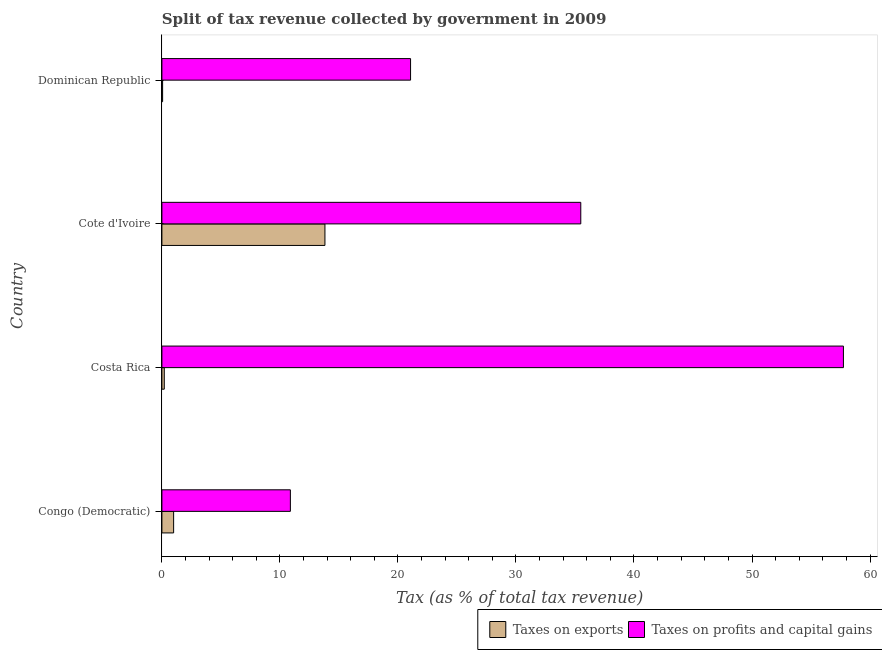How many different coloured bars are there?
Your answer should be very brief. 2. Are the number of bars per tick equal to the number of legend labels?
Give a very brief answer. Yes. Are the number of bars on each tick of the Y-axis equal?
Offer a very short reply. Yes. How many bars are there on the 4th tick from the bottom?
Give a very brief answer. 2. What is the percentage of revenue obtained from taxes on profits and capital gains in Dominican Republic?
Your answer should be compact. 21.07. Across all countries, what is the maximum percentage of revenue obtained from taxes on exports?
Your answer should be very brief. 13.81. Across all countries, what is the minimum percentage of revenue obtained from taxes on exports?
Make the answer very short. 0.06. In which country was the percentage of revenue obtained from taxes on exports maximum?
Give a very brief answer. Cote d'Ivoire. In which country was the percentage of revenue obtained from taxes on exports minimum?
Your answer should be compact. Dominican Republic. What is the total percentage of revenue obtained from taxes on exports in the graph?
Make the answer very short. 15.07. What is the difference between the percentage of revenue obtained from taxes on profits and capital gains in Costa Rica and that in Cote d'Ivoire?
Offer a very short reply. 22.25. What is the difference between the percentage of revenue obtained from taxes on profits and capital gains in Costa Rica and the percentage of revenue obtained from taxes on exports in Congo (Democratic)?
Offer a very short reply. 56.75. What is the average percentage of revenue obtained from taxes on profits and capital gains per country?
Your response must be concise. 31.3. What is the difference between the percentage of revenue obtained from taxes on exports and percentage of revenue obtained from taxes on profits and capital gains in Congo (Democratic)?
Your response must be concise. -9.89. What is the ratio of the percentage of revenue obtained from taxes on profits and capital gains in Costa Rica to that in Dominican Republic?
Ensure brevity in your answer.  2.74. What is the difference between the highest and the second highest percentage of revenue obtained from taxes on exports?
Ensure brevity in your answer.  12.82. What is the difference between the highest and the lowest percentage of revenue obtained from taxes on exports?
Offer a very short reply. 13.75. In how many countries, is the percentage of revenue obtained from taxes on profits and capital gains greater than the average percentage of revenue obtained from taxes on profits and capital gains taken over all countries?
Offer a terse response. 2. Is the sum of the percentage of revenue obtained from taxes on exports in Costa Rica and Cote d'Ivoire greater than the maximum percentage of revenue obtained from taxes on profits and capital gains across all countries?
Your answer should be very brief. No. What does the 1st bar from the top in Costa Rica represents?
Make the answer very short. Taxes on profits and capital gains. What does the 1st bar from the bottom in Dominican Republic represents?
Provide a short and direct response. Taxes on exports. How many bars are there?
Your answer should be very brief. 8. Are all the bars in the graph horizontal?
Your response must be concise. Yes. How many countries are there in the graph?
Your answer should be very brief. 4. Are the values on the major ticks of X-axis written in scientific E-notation?
Your response must be concise. No. Does the graph contain any zero values?
Keep it short and to the point. No. How many legend labels are there?
Give a very brief answer. 2. How are the legend labels stacked?
Offer a terse response. Horizontal. What is the title of the graph?
Make the answer very short. Split of tax revenue collected by government in 2009. Does "Gasoline" appear as one of the legend labels in the graph?
Give a very brief answer. No. What is the label or title of the X-axis?
Your response must be concise. Tax (as % of total tax revenue). What is the label or title of the Y-axis?
Your response must be concise. Country. What is the Tax (as % of total tax revenue) of Taxes on exports in Congo (Democratic)?
Provide a short and direct response. 0.99. What is the Tax (as % of total tax revenue) of Taxes on profits and capital gains in Congo (Democratic)?
Provide a short and direct response. 10.89. What is the Tax (as % of total tax revenue) in Taxes on exports in Costa Rica?
Offer a terse response. 0.2. What is the Tax (as % of total tax revenue) of Taxes on profits and capital gains in Costa Rica?
Your response must be concise. 57.75. What is the Tax (as % of total tax revenue) of Taxes on exports in Cote d'Ivoire?
Your answer should be compact. 13.81. What is the Tax (as % of total tax revenue) in Taxes on profits and capital gains in Cote d'Ivoire?
Your response must be concise. 35.49. What is the Tax (as % of total tax revenue) in Taxes on exports in Dominican Republic?
Your answer should be compact. 0.06. What is the Tax (as % of total tax revenue) in Taxes on profits and capital gains in Dominican Republic?
Offer a terse response. 21.07. Across all countries, what is the maximum Tax (as % of total tax revenue) of Taxes on exports?
Offer a terse response. 13.81. Across all countries, what is the maximum Tax (as % of total tax revenue) of Taxes on profits and capital gains?
Provide a short and direct response. 57.75. Across all countries, what is the minimum Tax (as % of total tax revenue) of Taxes on exports?
Offer a terse response. 0.06. Across all countries, what is the minimum Tax (as % of total tax revenue) in Taxes on profits and capital gains?
Give a very brief answer. 10.89. What is the total Tax (as % of total tax revenue) in Taxes on exports in the graph?
Keep it short and to the point. 15.07. What is the total Tax (as % of total tax revenue) of Taxes on profits and capital gains in the graph?
Provide a short and direct response. 125.19. What is the difference between the Tax (as % of total tax revenue) of Taxes on exports in Congo (Democratic) and that in Costa Rica?
Give a very brief answer. 0.79. What is the difference between the Tax (as % of total tax revenue) of Taxes on profits and capital gains in Congo (Democratic) and that in Costa Rica?
Your answer should be very brief. -46.86. What is the difference between the Tax (as % of total tax revenue) in Taxes on exports in Congo (Democratic) and that in Cote d'Ivoire?
Keep it short and to the point. -12.82. What is the difference between the Tax (as % of total tax revenue) of Taxes on profits and capital gains in Congo (Democratic) and that in Cote d'Ivoire?
Keep it short and to the point. -24.61. What is the difference between the Tax (as % of total tax revenue) of Taxes on exports in Congo (Democratic) and that in Dominican Republic?
Provide a succinct answer. 0.93. What is the difference between the Tax (as % of total tax revenue) in Taxes on profits and capital gains in Congo (Democratic) and that in Dominican Republic?
Ensure brevity in your answer.  -10.18. What is the difference between the Tax (as % of total tax revenue) in Taxes on exports in Costa Rica and that in Cote d'Ivoire?
Make the answer very short. -13.61. What is the difference between the Tax (as % of total tax revenue) of Taxes on profits and capital gains in Costa Rica and that in Cote d'Ivoire?
Keep it short and to the point. 22.25. What is the difference between the Tax (as % of total tax revenue) of Taxes on exports in Costa Rica and that in Dominican Republic?
Keep it short and to the point. 0.14. What is the difference between the Tax (as % of total tax revenue) of Taxes on profits and capital gains in Costa Rica and that in Dominican Republic?
Offer a terse response. 36.68. What is the difference between the Tax (as % of total tax revenue) of Taxes on exports in Cote d'Ivoire and that in Dominican Republic?
Keep it short and to the point. 13.75. What is the difference between the Tax (as % of total tax revenue) of Taxes on profits and capital gains in Cote d'Ivoire and that in Dominican Republic?
Your answer should be compact. 14.42. What is the difference between the Tax (as % of total tax revenue) in Taxes on exports in Congo (Democratic) and the Tax (as % of total tax revenue) in Taxes on profits and capital gains in Costa Rica?
Your answer should be compact. -56.75. What is the difference between the Tax (as % of total tax revenue) of Taxes on exports in Congo (Democratic) and the Tax (as % of total tax revenue) of Taxes on profits and capital gains in Cote d'Ivoire?
Your answer should be very brief. -34.5. What is the difference between the Tax (as % of total tax revenue) in Taxes on exports in Congo (Democratic) and the Tax (as % of total tax revenue) in Taxes on profits and capital gains in Dominican Republic?
Your response must be concise. -20.08. What is the difference between the Tax (as % of total tax revenue) of Taxes on exports in Costa Rica and the Tax (as % of total tax revenue) of Taxes on profits and capital gains in Cote d'Ivoire?
Offer a very short reply. -35.29. What is the difference between the Tax (as % of total tax revenue) in Taxes on exports in Costa Rica and the Tax (as % of total tax revenue) in Taxes on profits and capital gains in Dominican Republic?
Your answer should be very brief. -20.87. What is the difference between the Tax (as % of total tax revenue) in Taxes on exports in Cote d'Ivoire and the Tax (as % of total tax revenue) in Taxes on profits and capital gains in Dominican Republic?
Keep it short and to the point. -7.26. What is the average Tax (as % of total tax revenue) in Taxes on exports per country?
Make the answer very short. 3.77. What is the average Tax (as % of total tax revenue) in Taxes on profits and capital gains per country?
Your answer should be very brief. 31.3. What is the difference between the Tax (as % of total tax revenue) in Taxes on exports and Tax (as % of total tax revenue) in Taxes on profits and capital gains in Congo (Democratic)?
Ensure brevity in your answer.  -9.89. What is the difference between the Tax (as % of total tax revenue) in Taxes on exports and Tax (as % of total tax revenue) in Taxes on profits and capital gains in Costa Rica?
Offer a terse response. -57.54. What is the difference between the Tax (as % of total tax revenue) of Taxes on exports and Tax (as % of total tax revenue) of Taxes on profits and capital gains in Cote d'Ivoire?
Give a very brief answer. -21.68. What is the difference between the Tax (as % of total tax revenue) of Taxes on exports and Tax (as % of total tax revenue) of Taxes on profits and capital gains in Dominican Republic?
Offer a very short reply. -21.01. What is the ratio of the Tax (as % of total tax revenue) in Taxes on exports in Congo (Democratic) to that in Costa Rica?
Your response must be concise. 4.93. What is the ratio of the Tax (as % of total tax revenue) in Taxes on profits and capital gains in Congo (Democratic) to that in Costa Rica?
Your answer should be very brief. 0.19. What is the ratio of the Tax (as % of total tax revenue) in Taxes on exports in Congo (Democratic) to that in Cote d'Ivoire?
Your answer should be very brief. 0.07. What is the ratio of the Tax (as % of total tax revenue) of Taxes on profits and capital gains in Congo (Democratic) to that in Cote d'Ivoire?
Give a very brief answer. 0.31. What is the ratio of the Tax (as % of total tax revenue) of Taxes on exports in Congo (Democratic) to that in Dominican Republic?
Provide a succinct answer. 16.54. What is the ratio of the Tax (as % of total tax revenue) of Taxes on profits and capital gains in Congo (Democratic) to that in Dominican Republic?
Your response must be concise. 0.52. What is the ratio of the Tax (as % of total tax revenue) of Taxes on exports in Costa Rica to that in Cote d'Ivoire?
Provide a succinct answer. 0.01. What is the ratio of the Tax (as % of total tax revenue) of Taxes on profits and capital gains in Costa Rica to that in Cote d'Ivoire?
Offer a terse response. 1.63. What is the ratio of the Tax (as % of total tax revenue) of Taxes on exports in Costa Rica to that in Dominican Republic?
Your answer should be very brief. 3.35. What is the ratio of the Tax (as % of total tax revenue) in Taxes on profits and capital gains in Costa Rica to that in Dominican Republic?
Keep it short and to the point. 2.74. What is the ratio of the Tax (as % of total tax revenue) in Taxes on exports in Cote d'Ivoire to that in Dominican Republic?
Provide a succinct answer. 230.16. What is the ratio of the Tax (as % of total tax revenue) of Taxes on profits and capital gains in Cote d'Ivoire to that in Dominican Republic?
Your answer should be compact. 1.68. What is the difference between the highest and the second highest Tax (as % of total tax revenue) in Taxes on exports?
Give a very brief answer. 12.82. What is the difference between the highest and the second highest Tax (as % of total tax revenue) of Taxes on profits and capital gains?
Make the answer very short. 22.25. What is the difference between the highest and the lowest Tax (as % of total tax revenue) in Taxes on exports?
Your answer should be compact. 13.75. What is the difference between the highest and the lowest Tax (as % of total tax revenue) of Taxes on profits and capital gains?
Your response must be concise. 46.86. 